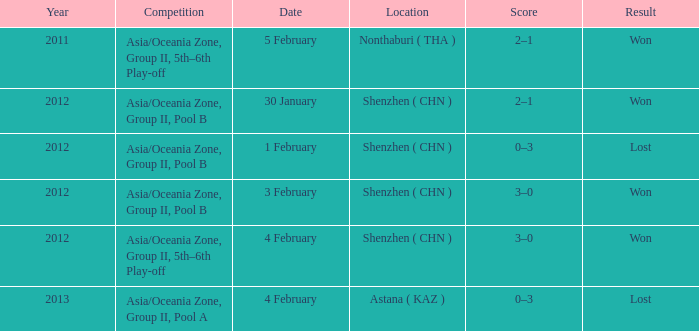What was the location for a year later than 2012? Astana ( KAZ ). 